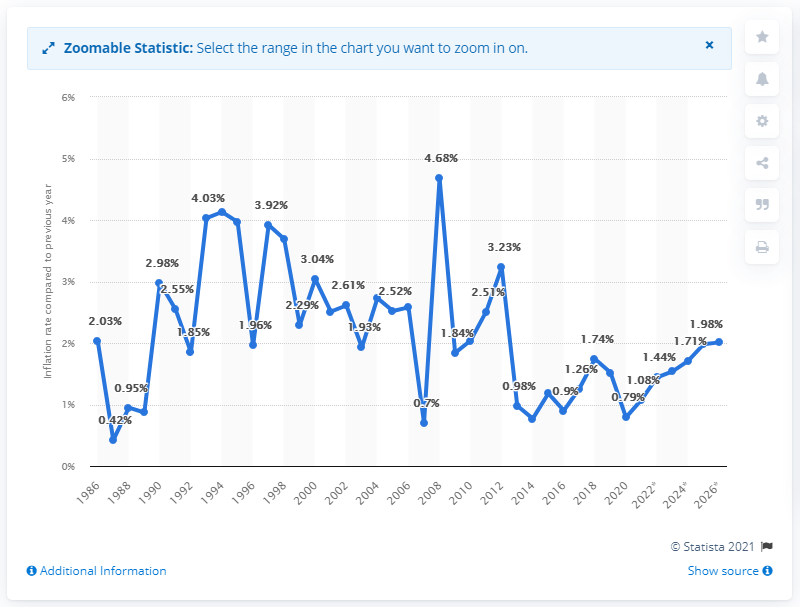Highlight a few significant elements in this photo. The inflation rate in Malta in 2020 was 0.79%. 